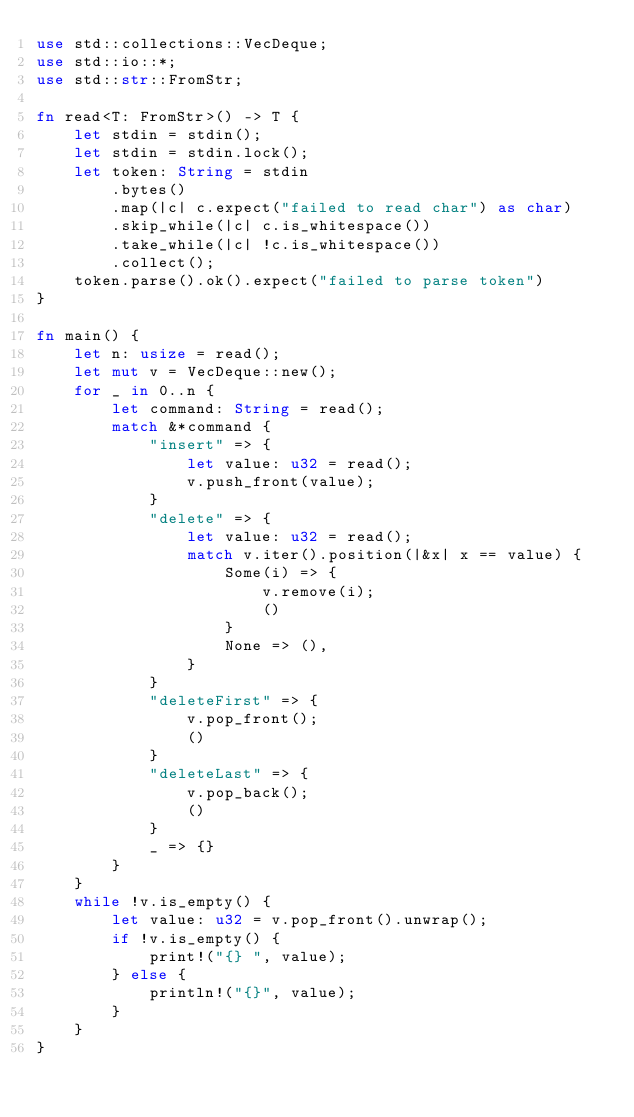Convert code to text. <code><loc_0><loc_0><loc_500><loc_500><_Rust_>use std::collections::VecDeque;
use std::io::*;
use std::str::FromStr;

fn read<T: FromStr>() -> T {
    let stdin = stdin();
    let stdin = stdin.lock();
    let token: String = stdin
        .bytes()
        .map(|c| c.expect("failed to read char") as char)
        .skip_while(|c| c.is_whitespace())
        .take_while(|c| !c.is_whitespace())
        .collect();
    token.parse().ok().expect("failed to parse token")
}

fn main() {
    let n: usize = read();
    let mut v = VecDeque::new();
    for _ in 0..n {
        let command: String = read();
        match &*command {
            "insert" => {
                let value: u32 = read();
                v.push_front(value);
            }
            "delete" => {
                let value: u32 = read();
                match v.iter().position(|&x| x == value) {
                    Some(i) => {
                        v.remove(i);
                        ()
                    }
                    None => (),
                }
            }
            "deleteFirst" => {
                v.pop_front();
                ()
            }
            "deleteLast" => {
                v.pop_back();
                ()
            }
            _ => {}
        }
    }
    while !v.is_empty() {
        let value: u32 = v.pop_front().unwrap();
        if !v.is_empty() {
            print!("{} ", value);
        } else {
            println!("{}", value);
        }
    }
}

</code> 